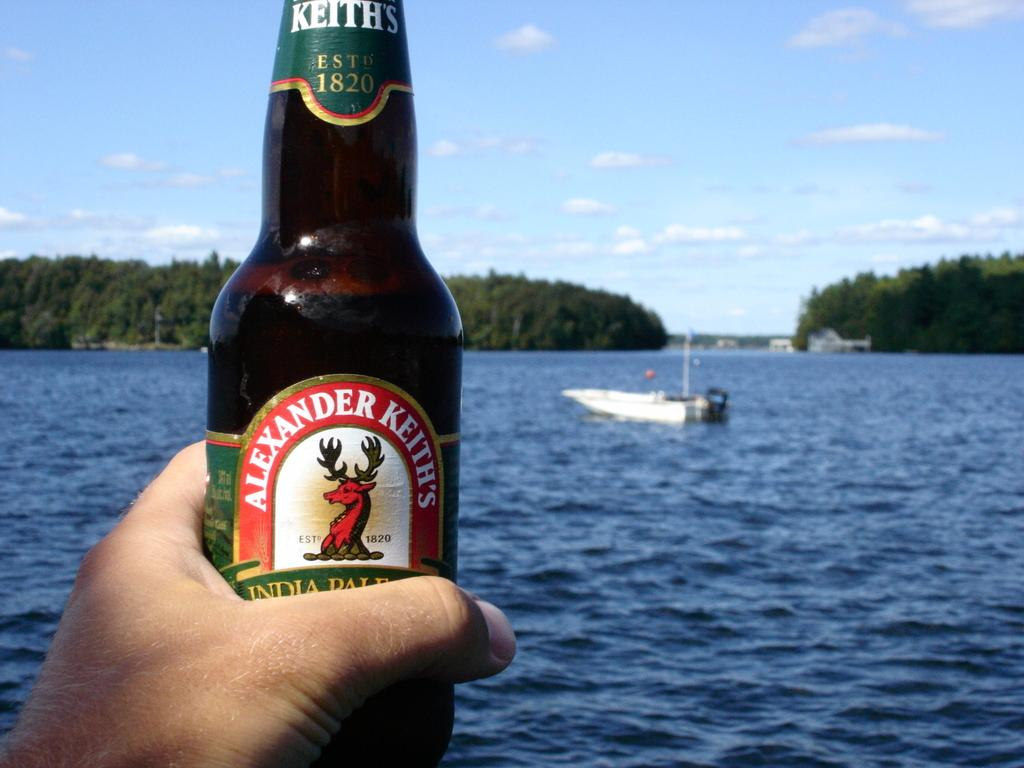<image>
Create a compact narrative representing the image presented. A hand holds up a bottle of Alexander Keith's IPA, with a lake in the background. 